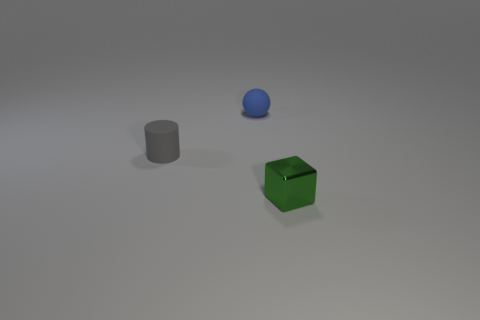Are there any rubber balls of the same size as the metal cube?
Offer a terse response. Yes. Is the material of the blue ball the same as the small thing that is on the right side of the blue rubber thing?
Keep it short and to the point. No. Are there more big green matte things than gray matte things?
Provide a short and direct response. No. What number of cubes are either small green objects or tiny gray objects?
Offer a terse response. 1. What color is the tiny rubber ball?
Provide a succinct answer. Blue. Does the matte object that is in front of the blue matte object have the same size as the object that is in front of the gray thing?
Offer a terse response. Yes. Are there fewer tiny gray matte cylinders than small red matte objects?
Provide a succinct answer. No. There is a gray object; how many green cubes are behind it?
Make the answer very short. 0. What is the green cube made of?
Provide a short and direct response. Metal. Do the sphere and the metal object have the same color?
Provide a short and direct response. No. 